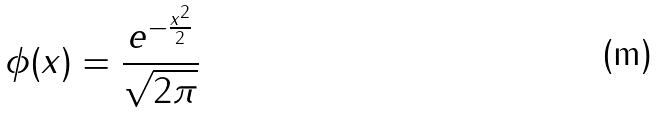<formula> <loc_0><loc_0><loc_500><loc_500>\phi ( x ) = \frac { e ^ { - \frac { x ^ { 2 } } { 2 } } } { \sqrt { 2 \pi } }</formula> 